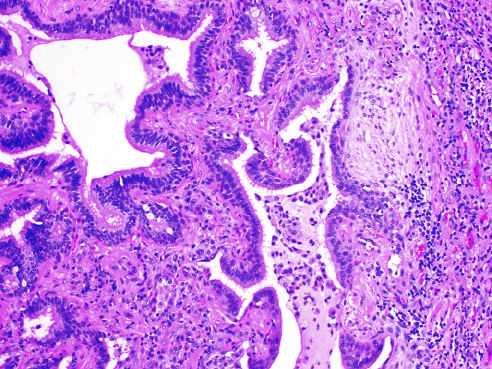s schematic diagram of intimal thickening present to the left?
Answer the question using a single word or phrase. No 